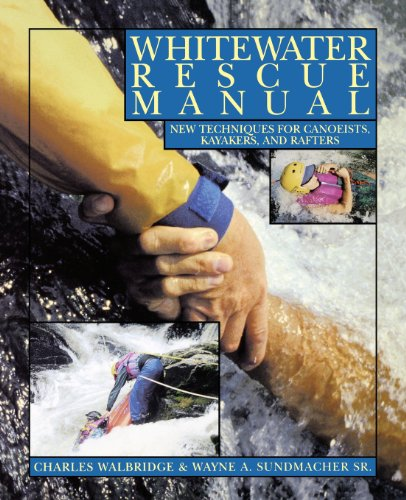Who wrote this book? The book, 'Whitewater Rescue Manual: New Techniques for Canoeists, Kayakers, and Rafters', was authored by Charles Walbridge and Wayne A. Sundmacher Sr. 